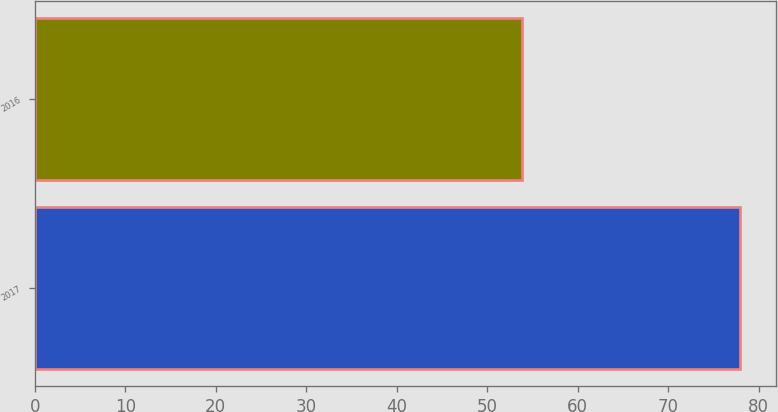Convert chart. <chart><loc_0><loc_0><loc_500><loc_500><bar_chart><fcel>2017<fcel>2016<nl><fcel>77.97<fcel>53.88<nl></chart> 